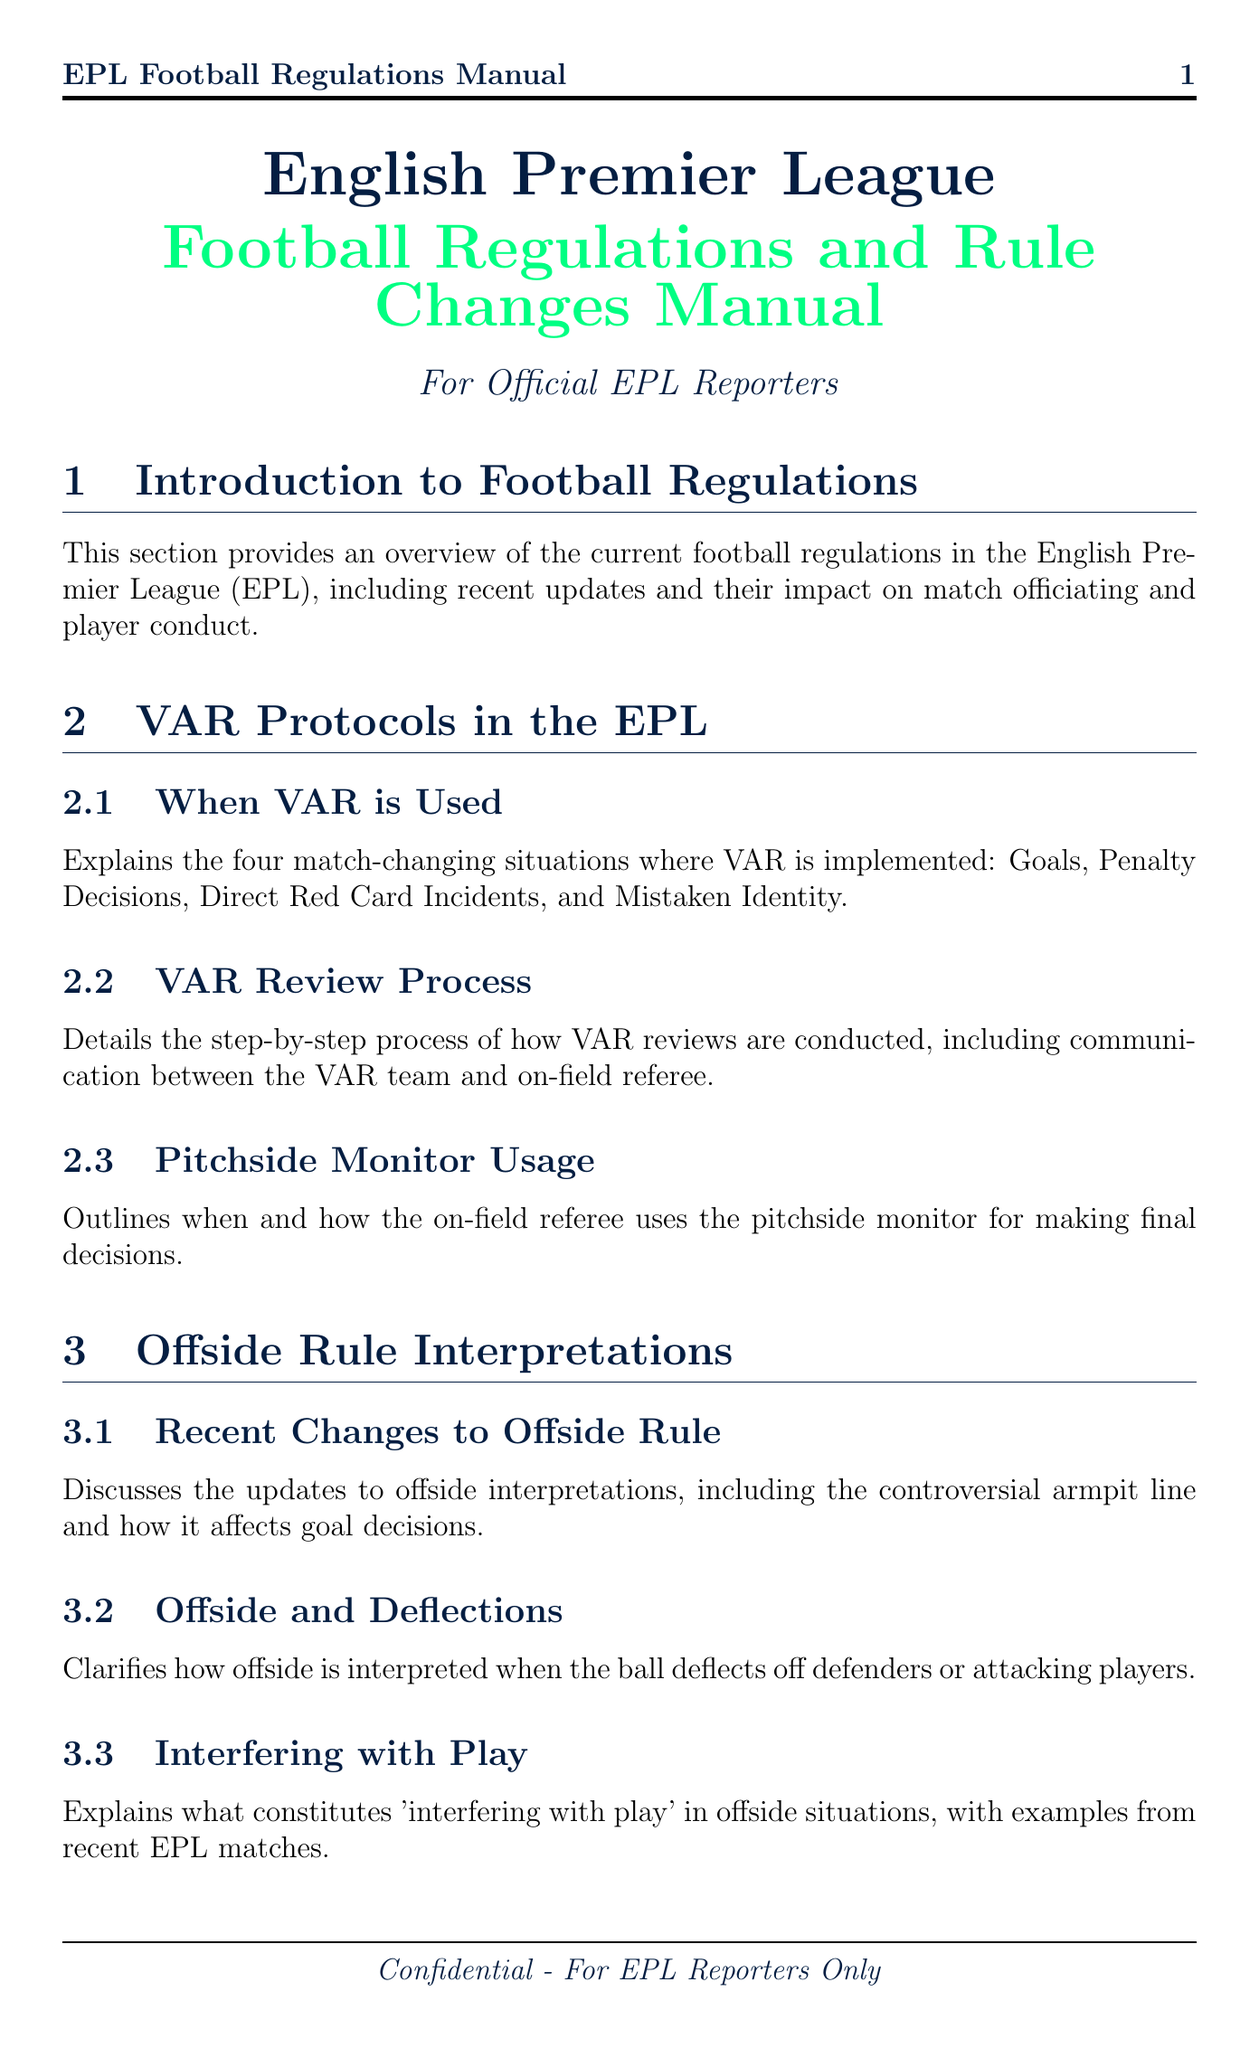What is the title of the document? The title is mentioned in the header of the document as "English Premier League Football Regulations and Rule Changes Manual".
Answer: English Premier League Football Regulations and Rule Changes Manual What are the four situations where VAR is used? The document specifies that VAR is implemented for Goals, Penalty Decisions, Direct Red Card Incidents, and Mistaken Identity.
Answer: Goals, Penalty Decisions, Direct Red Card Incidents, Mistaken Identity What does the handball rule change involve? The document describes the removal of accidental handball leading to a goal for a teammate as part of the evolving handball rule.
Answer: Removal of accidental handball leading to a goal for a teammate How many substitutions are currently allowed in the EPL? The document explains that the current substitution allowances include the continued use of five substitutions.
Answer: Five substitutions What is required for homegrown players in squad registration? The document outlines the EPL's requirements, which pertain to homegrown players in the context of squad registration.
Answer: Homegrown players in squad registration What is the purpose of Goal Line Technology? The document explains that Goal Line Technology works in conjunction with VAR to determine if the ball has fully crossed the goal line.
Answer: Determine if the ball has fully crossed the goal line What does the report on rule changes provide? The document provides guidelines for football reporters on accurately communicating rule changes and interpretations.
Answer: Guidelines for football reporters What examples are mentioned for 'interfering with play'? The document states it includes examples from recent EPL matches regarding what constitutes 'interfering with play'.
Answer: Examples from recent EPL matches 